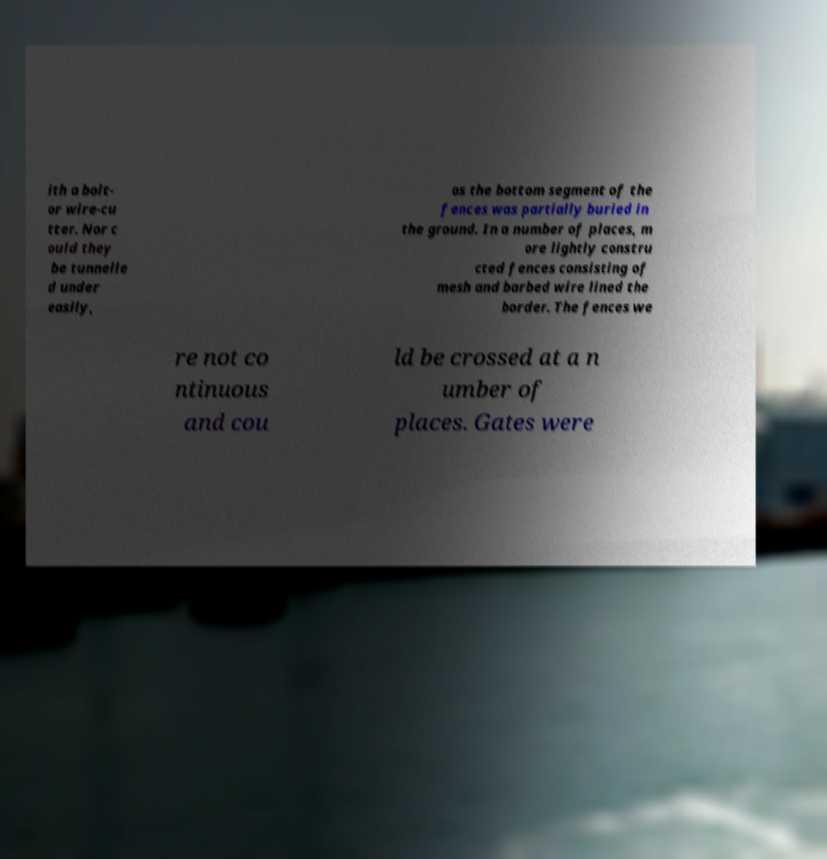Could you extract and type out the text from this image? ith a bolt- or wire-cu tter. Nor c ould they be tunnelle d under easily, as the bottom segment of the fences was partially buried in the ground. In a number of places, m ore lightly constru cted fences consisting of mesh and barbed wire lined the border. The fences we re not co ntinuous and cou ld be crossed at a n umber of places. Gates were 